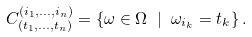Convert formula to latex. <formula><loc_0><loc_0><loc_500><loc_500>C _ { \left ( t _ { 1 } , \dots , t _ { n } \right ) } ^ { \left ( i _ { 1 } , \dots , i _ { n } \right ) } = \left \{ \omega \in \Omega \ | \ \omega _ { i _ { k } } = t _ { k } \right \} .</formula> 